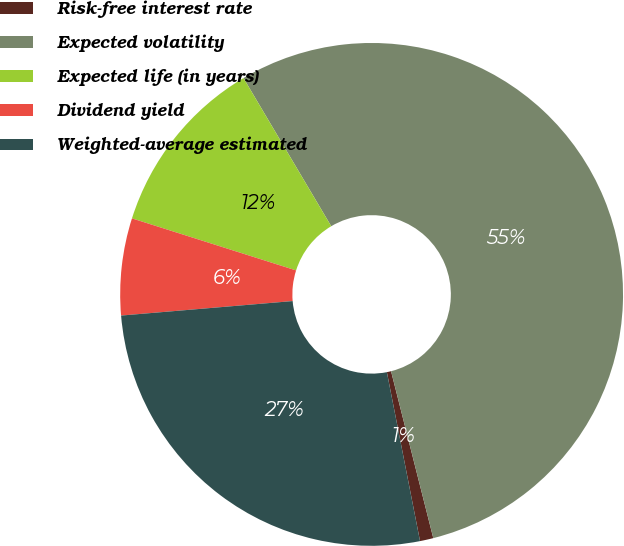Convert chart to OTSL. <chart><loc_0><loc_0><loc_500><loc_500><pie_chart><fcel>Risk-free interest rate<fcel>Expected volatility<fcel>Expected life (in years)<fcel>Dividend yield<fcel>Weighted-average estimated<nl><fcel>0.86%<fcel>54.56%<fcel>11.6%<fcel>6.23%<fcel>26.74%<nl></chart> 